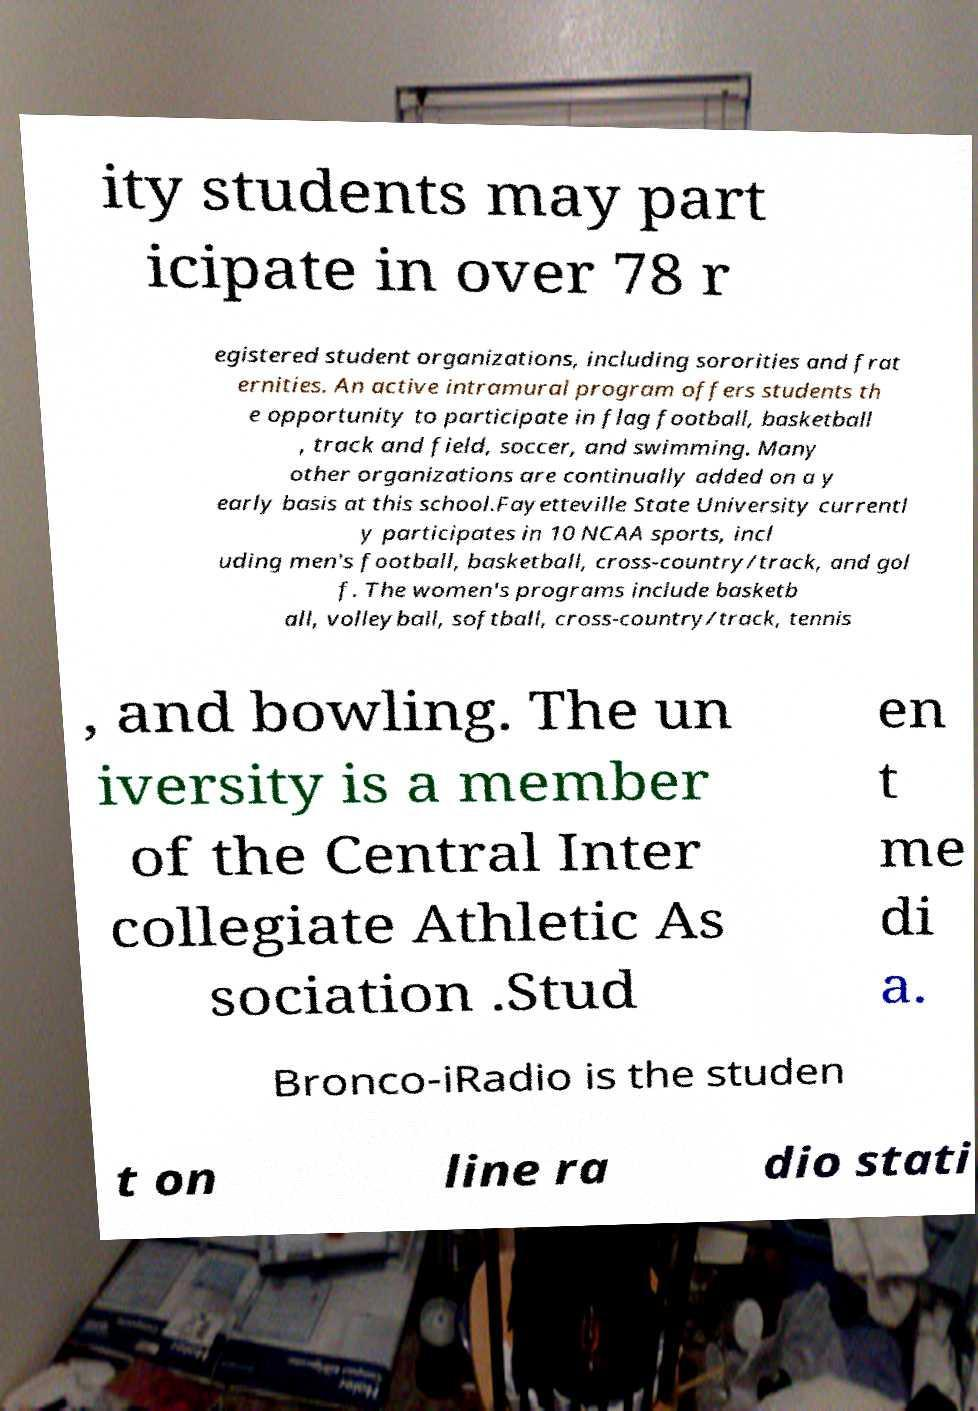For documentation purposes, I need the text within this image transcribed. Could you provide that? ity students may part icipate in over 78 r egistered student organizations, including sororities and frat ernities. An active intramural program offers students th e opportunity to participate in flag football, basketball , track and field, soccer, and swimming. Many other organizations are continually added on a y early basis at this school.Fayetteville State University currentl y participates in 10 NCAA sports, incl uding men's football, basketball, cross-country/track, and gol f. The women's programs include basketb all, volleyball, softball, cross-country/track, tennis , and bowling. The un iversity is a member of the Central Inter collegiate Athletic As sociation .Stud en t me di a. Bronco-iRadio is the studen t on line ra dio stati 